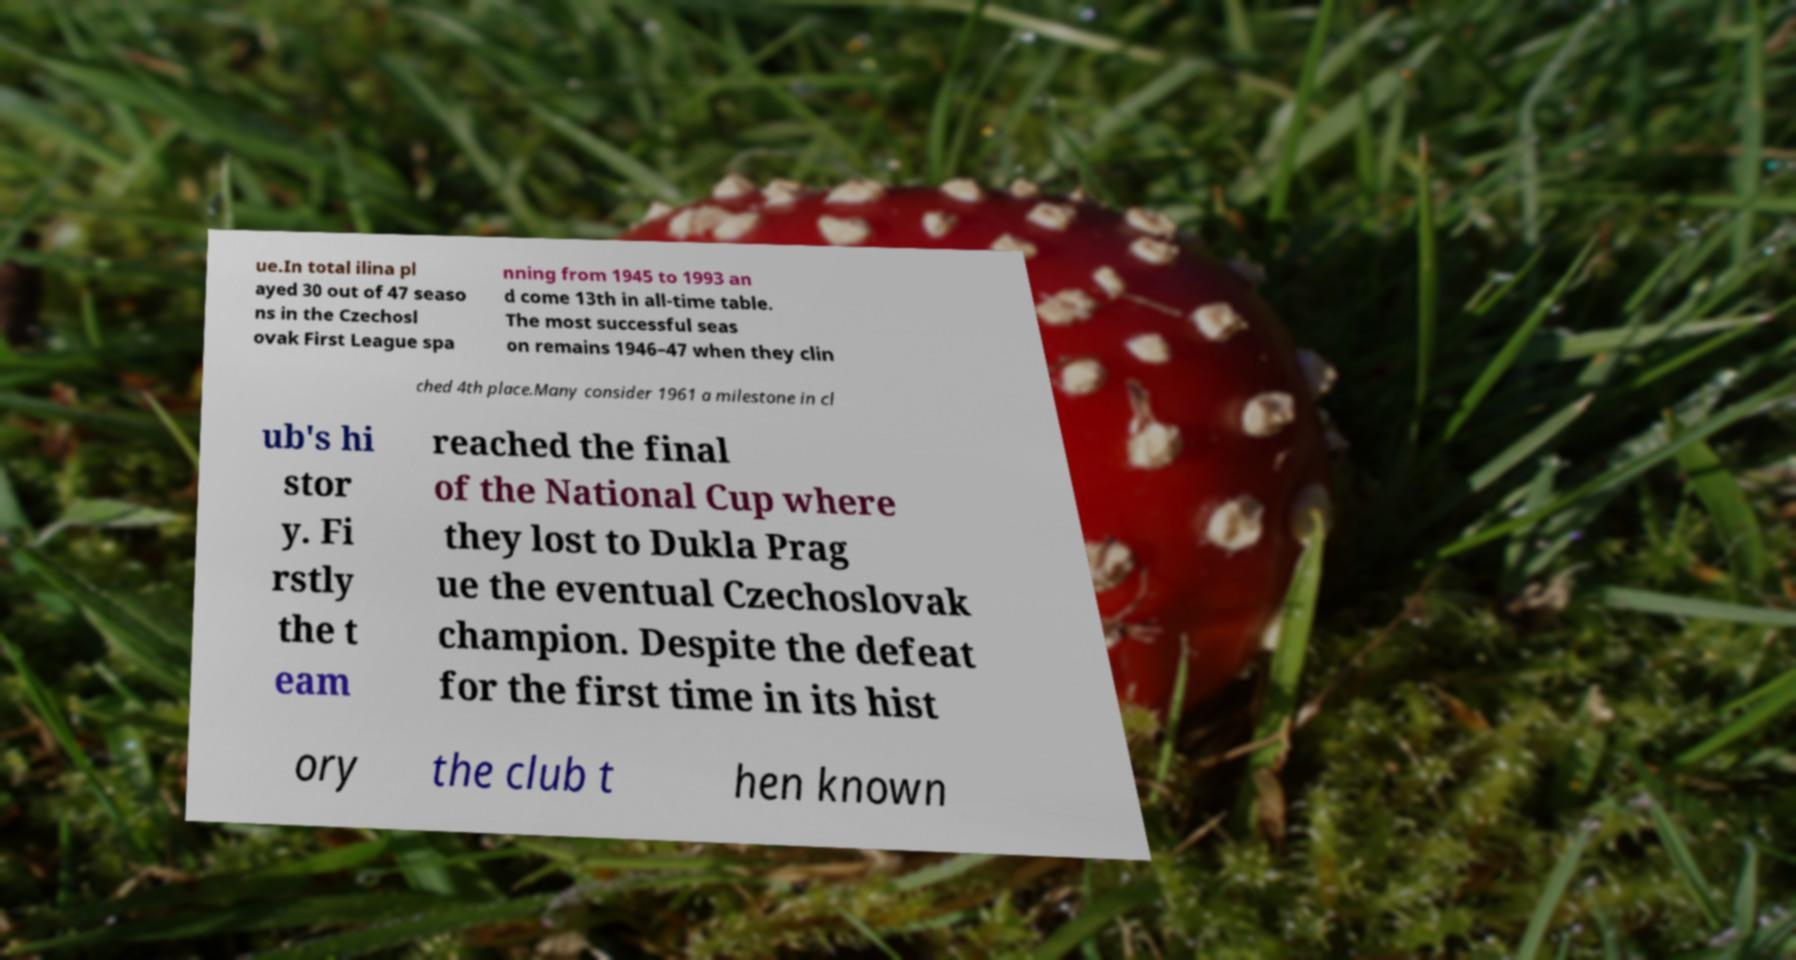There's text embedded in this image that I need extracted. Can you transcribe it verbatim? ue.In total ilina pl ayed 30 out of 47 seaso ns in the Czechosl ovak First League spa nning from 1945 to 1993 an d come 13th in all-time table. The most successful seas on remains 1946–47 when they clin ched 4th place.Many consider 1961 a milestone in cl ub's hi stor y. Fi rstly the t eam reached the final of the National Cup where they lost to Dukla Prag ue the eventual Czechoslovak champion. Despite the defeat for the first time in its hist ory the club t hen known 